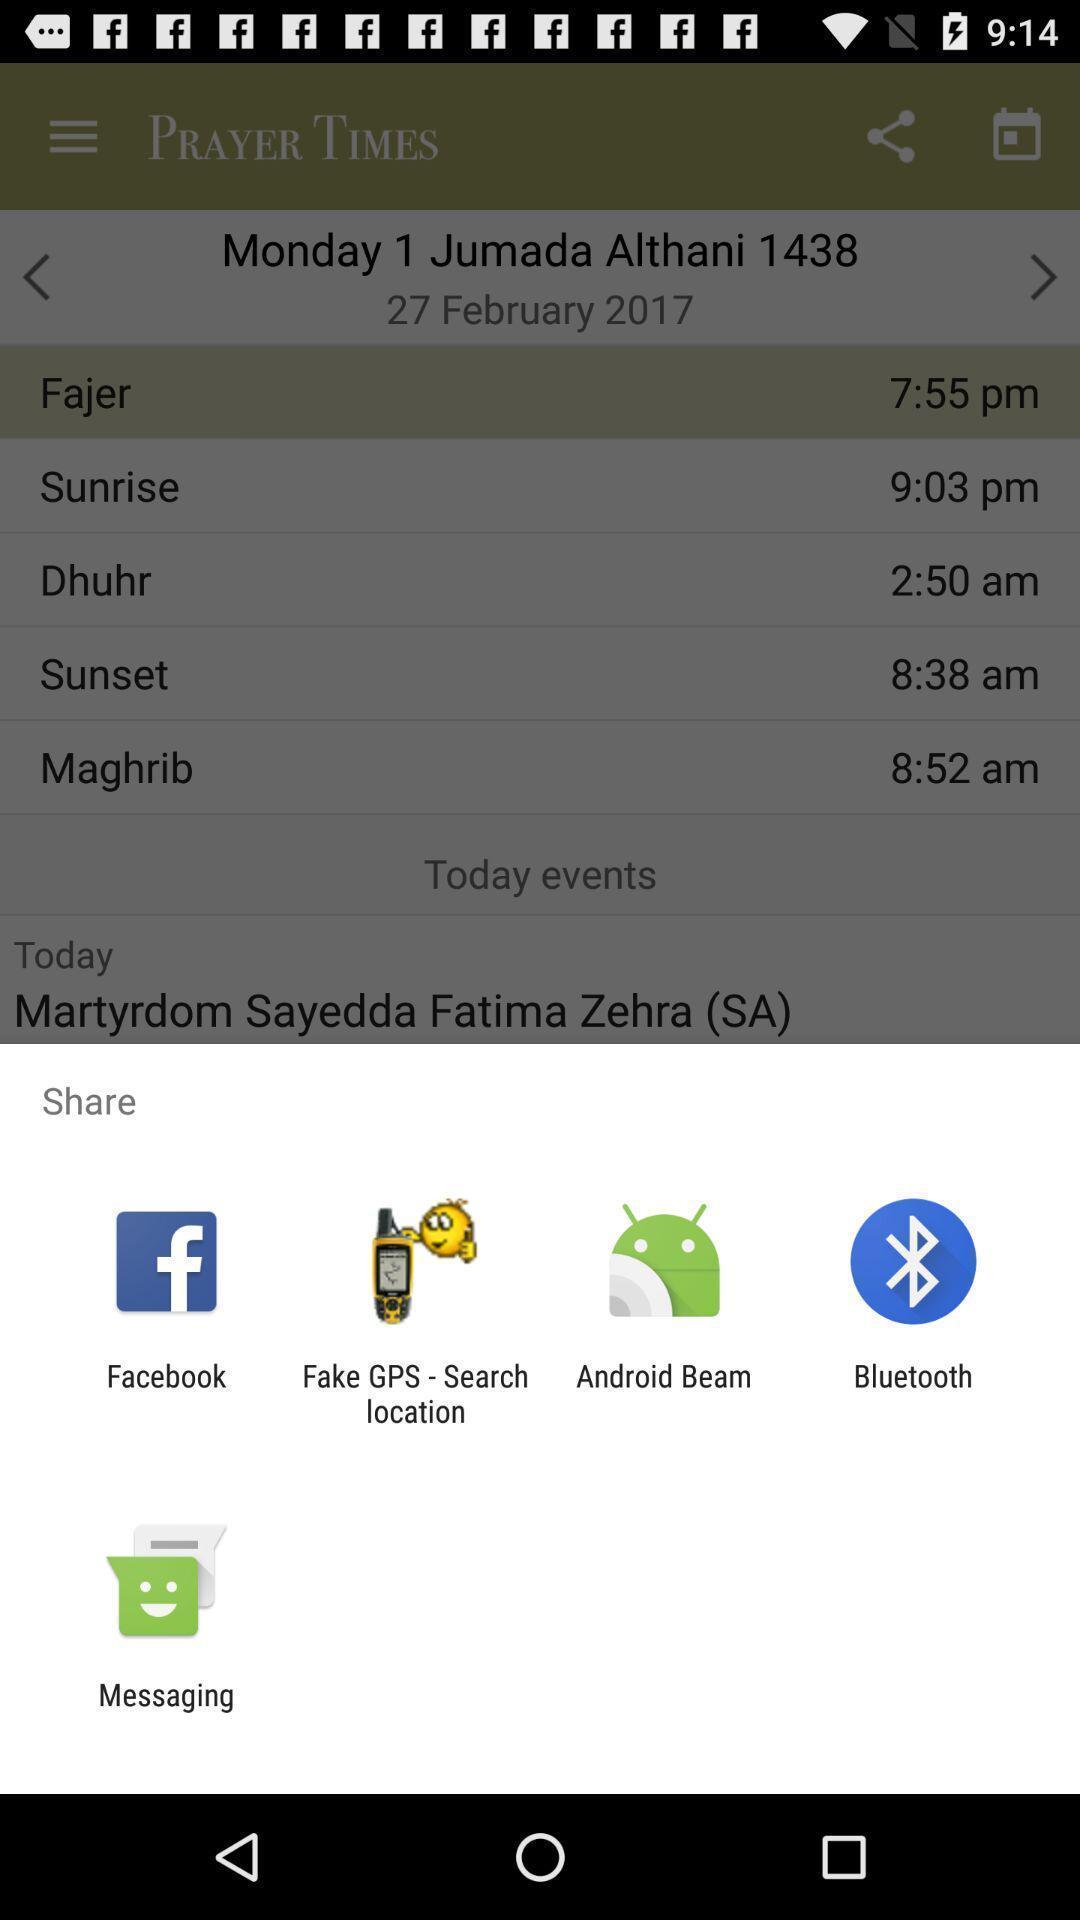Provide a description of this screenshot. Pop-up showing various share options. 